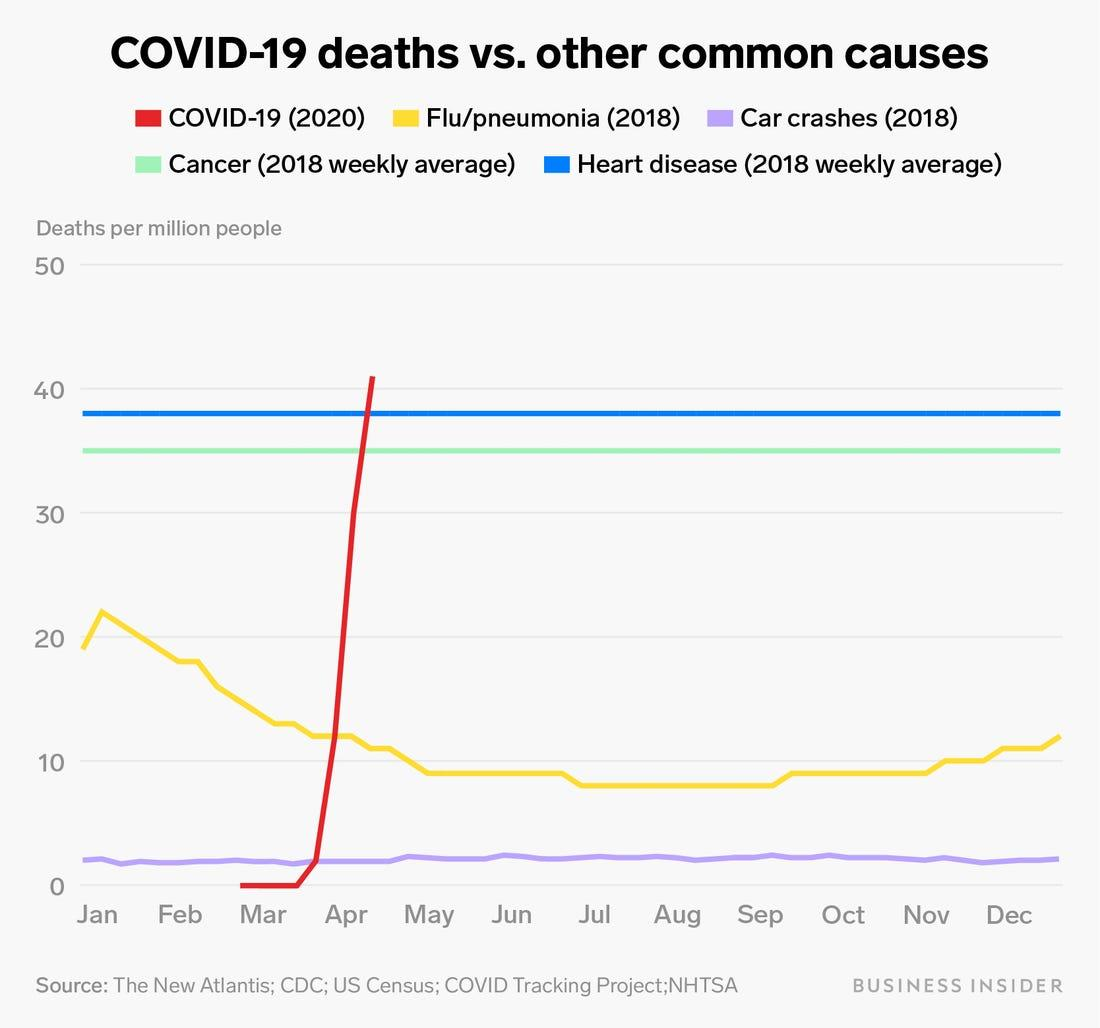List a handful of essential elements in this visual. The cause of death that has remained relatively stable from January to December is cancer and heart disease. The flu/pneumonia disease has seen a significant increase in January. In January, the death rate due to flu and pneumonia exceeded 20 per million. The color that represents COVID-19 deaths is red. During the pandemic, the highest number of COVID-19 deaths occurred in the months of March and April. 